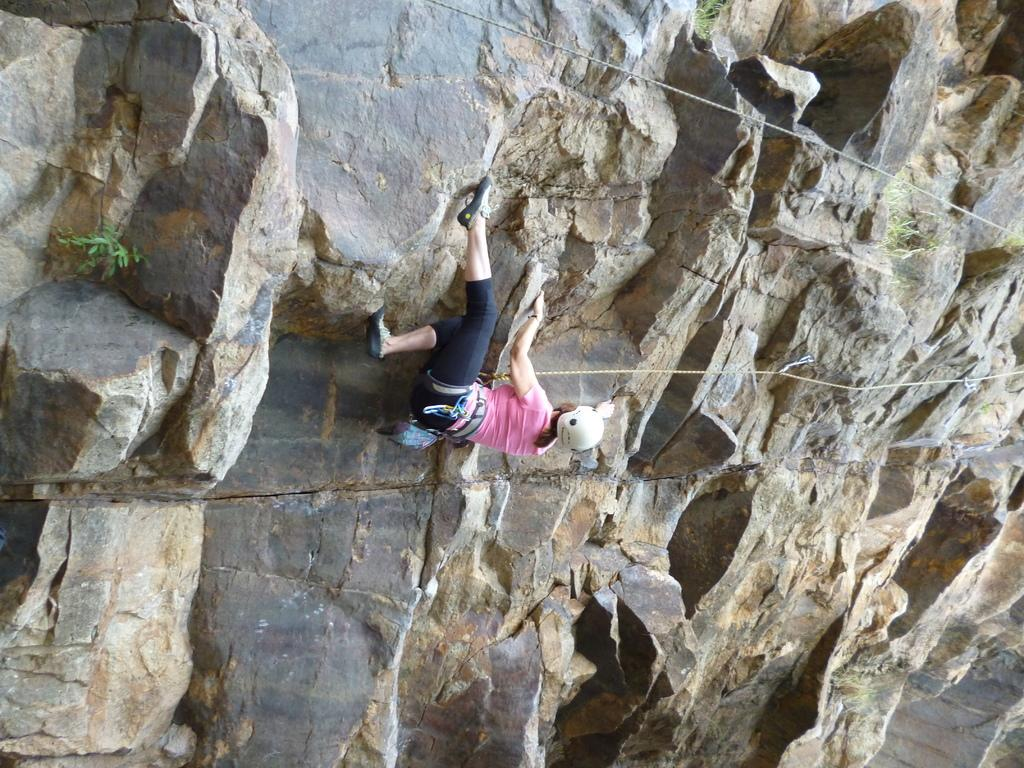Who is the main subject in the image? There is a woman in the image. What is the woman doing in the image? The woman is climbing a hill. How is the woman assisted in her climb? The woman is using a rope for assistance. What safety gear is the woman wearing? The woman is wearing a helmet. What can be seen in the background of the image? There is a hill visible in the background of the image. What type of surprise is the woman holding in her hand while climbing the hill? There is no indication in the image that the woman is holding a surprise or any object in her hand. 